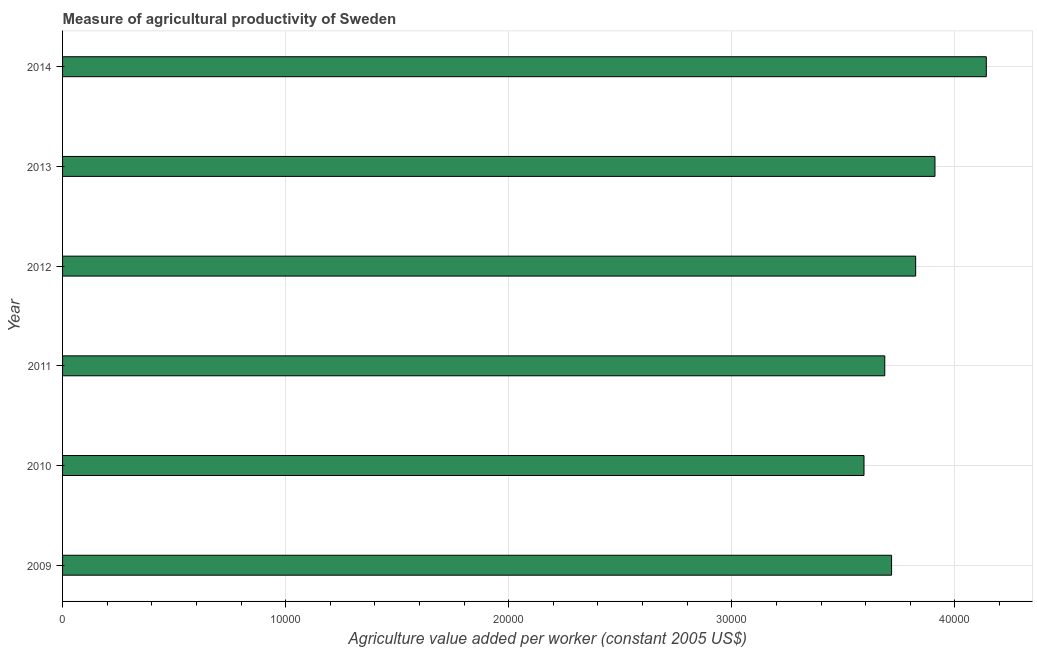Does the graph contain grids?
Offer a very short reply. Yes. What is the title of the graph?
Your answer should be compact. Measure of agricultural productivity of Sweden. What is the label or title of the X-axis?
Ensure brevity in your answer.  Agriculture value added per worker (constant 2005 US$). What is the label or title of the Y-axis?
Offer a very short reply. Year. What is the agriculture value added per worker in 2012?
Provide a succinct answer. 3.82e+04. Across all years, what is the maximum agriculture value added per worker?
Make the answer very short. 4.14e+04. Across all years, what is the minimum agriculture value added per worker?
Your response must be concise. 3.59e+04. In which year was the agriculture value added per worker maximum?
Your answer should be very brief. 2014. In which year was the agriculture value added per worker minimum?
Make the answer very short. 2010. What is the sum of the agriculture value added per worker?
Your answer should be compact. 2.29e+05. What is the difference between the agriculture value added per worker in 2010 and 2011?
Offer a terse response. -931.52. What is the average agriculture value added per worker per year?
Ensure brevity in your answer.  3.81e+04. What is the median agriculture value added per worker?
Offer a very short reply. 3.77e+04. In how many years, is the agriculture value added per worker greater than 38000 US$?
Keep it short and to the point. 3. Do a majority of the years between 2014 and 2012 (inclusive) have agriculture value added per worker greater than 6000 US$?
Your answer should be compact. Yes. Is the agriculture value added per worker in 2010 less than that in 2013?
Make the answer very short. Yes. Is the difference between the agriculture value added per worker in 2009 and 2012 greater than the difference between any two years?
Make the answer very short. No. What is the difference between the highest and the second highest agriculture value added per worker?
Make the answer very short. 2301.68. Is the sum of the agriculture value added per worker in 2012 and 2014 greater than the maximum agriculture value added per worker across all years?
Provide a succinct answer. Yes. What is the difference between the highest and the lowest agriculture value added per worker?
Provide a succinct answer. 5483.15. In how many years, is the agriculture value added per worker greater than the average agriculture value added per worker taken over all years?
Ensure brevity in your answer.  3. What is the Agriculture value added per worker (constant 2005 US$) in 2009?
Keep it short and to the point. 3.72e+04. What is the Agriculture value added per worker (constant 2005 US$) in 2010?
Your answer should be very brief. 3.59e+04. What is the Agriculture value added per worker (constant 2005 US$) of 2011?
Offer a very short reply. 3.69e+04. What is the Agriculture value added per worker (constant 2005 US$) of 2012?
Offer a very short reply. 3.82e+04. What is the Agriculture value added per worker (constant 2005 US$) in 2013?
Provide a succinct answer. 3.91e+04. What is the Agriculture value added per worker (constant 2005 US$) in 2014?
Offer a very short reply. 4.14e+04. What is the difference between the Agriculture value added per worker (constant 2005 US$) in 2009 and 2010?
Your response must be concise. 1236.7. What is the difference between the Agriculture value added per worker (constant 2005 US$) in 2009 and 2011?
Your answer should be very brief. 305.18. What is the difference between the Agriculture value added per worker (constant 2005 US$) in 2009 and 2012?
Your response must be concise. -1080.26. What is the difference between the Agriculture value added per worker (constant 2005 US$) in 2009 and 2013?
Provide a succinct answer. -1944.77. What is the difference between the Agriculture value added per worker (constant 2005 US$) in 2009 and 2014?
Offer a very short reply. -4246.45. What is the difference between the Agriculture value added per worker (constant 2005 US$) in 2010 and 2011?
Make the answer very short. -931.52. What is the difference between the Agriculture value added per worker (constant 2005 US$) in 2010 and 2012?
Make the answer very short. -2316.96. What is the difference between the Agriculture value added per worker (constant 2005 US$) in 2010 and 2013?
Provide a short and direct response. -3181.47. What is the difference between the Agriculture value added per worker (constant 2005 US$) in 2010 and 2014?
Ensure brevity in your answer.  -5483.15. What is the difference between the Agriculture value added per worker (constant 2005 US$) in 2011 and 2012?
Make the answer very short. -1385.44. What is the difference between the Agriculture value added per worker (constant 2005 US$) in 2011 and 2013?
Your response must be concise. -2249.95. What is the difference between the Agriculture value added per worker (constant 2005 US$) in 2011 and 2014?
Offer a terse response. -4551.64. What is the difference between the Agriculture value added per worker (constant 2005 US$) in 2012 and 2013?
Provide a succinct answer. -864.51. What is the difference between the Agriculture value added per worker (constant 2005 US$) in 2012 and 2014?
Offer a very short reply. -3166.2. What is the difference between the Agriculture value added per worker (constant 2005 US$) in 2013 and 2014?
Offer a very short reply. -2301.68. What is the ratio of the Agriculture value added per worker (constant 2005 US$) in 2009 to that in 2010?
Provide a short and direct response. 1.03. What is the ratio of the Agriculture value added per worker (constant 2005 US$) in 2009 to that in 2011?
Give a very brief answer. 1.01. What is the ratio of the Agriculture value added per worker (constant 2005 US$) in 2009 to that in 2012?
Your response must be concise. 0.97. What is the ratio of the Agriculture value added per worker (constant 2005 US$) in 2009 to that in 2014?
Offer a terse response. 0.9. What is the ratio of the Agriculture value added per worker (constant 2005 US$) in 2010 to that in 2011?
Ensure brevity in your answer.  0.97. What is the ratio of the Agriculture value added per worker (constant 2005 US$) in 2010 to that in 2012?
Provide a succinct answer. 0.94. What is the ratio of the Agriculture value added per worker (constant 2005 US$) in 2010 to that in 2013?
Make the answer very short. 0.92. What is the ratio of the Agriculture value added per worker (constant 2005 US$) in 2010 to that in 2014?
Your response must be concise. 0.87. What is the ratio of the Agriculture value added per worker (constant 2005 US$) in 2011 to that in 2012?
Your response must be concise. 0.96. What is the ratio of the Agriculture value added per worker (constant 2005 US$) in 2011 to that in 2013?
Provide a succinct answer. 0.94. What is the ratio of the Agriculture value added per worker (constant 2005 US$) in 2011 to that in 2014?
Provide a succinct answer. 0.89. What is the ratio of the Agriculture value added per worker (constant 2005 US$) in 2012 to that in 2013?
Your response must be concise. 0.98. What is the ratio of the Agriculture value added per worker (constant 2005 US$) in 2012 to that in 2014?
Make the answer very short. 0.92. What is the ratio of the Agriculture value added per worker (constant 2005 US$) in 2013 to that in 2014?
Provide a short and direct response. 0.94. 